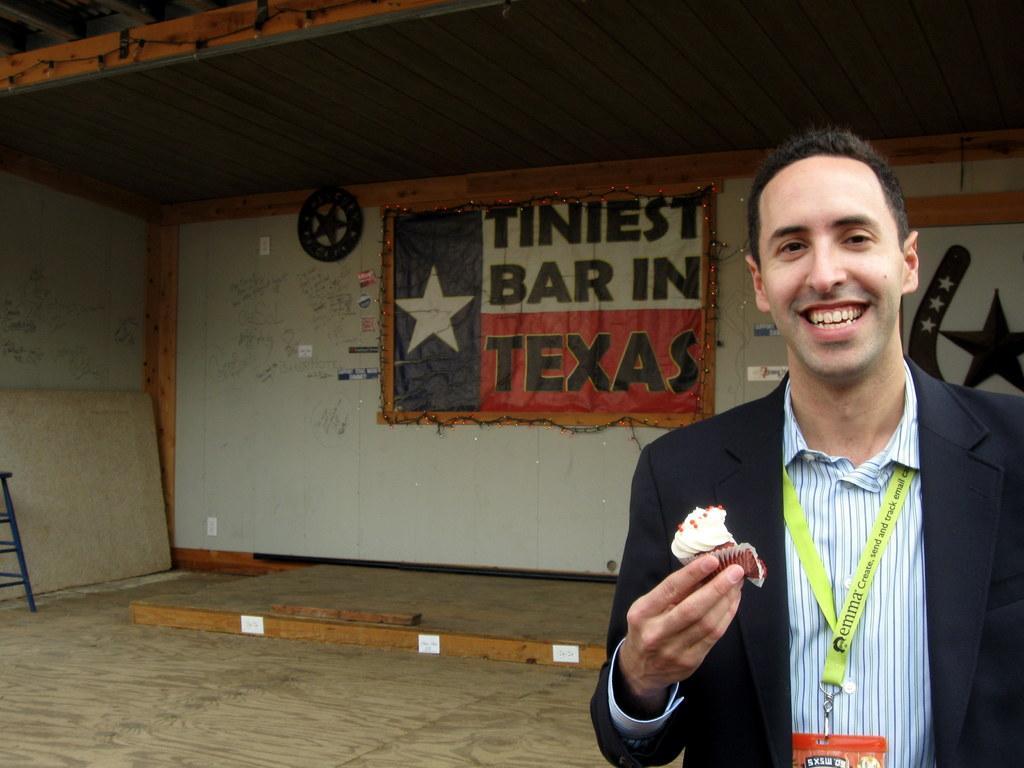In one or two sentences, can you explain what this image depicts? In this image I can see a person wearing white shirt and black blazer is standing and holding a cupcake in his hand. In the background I can see the floor, the wall, a banner and the ceiling. 